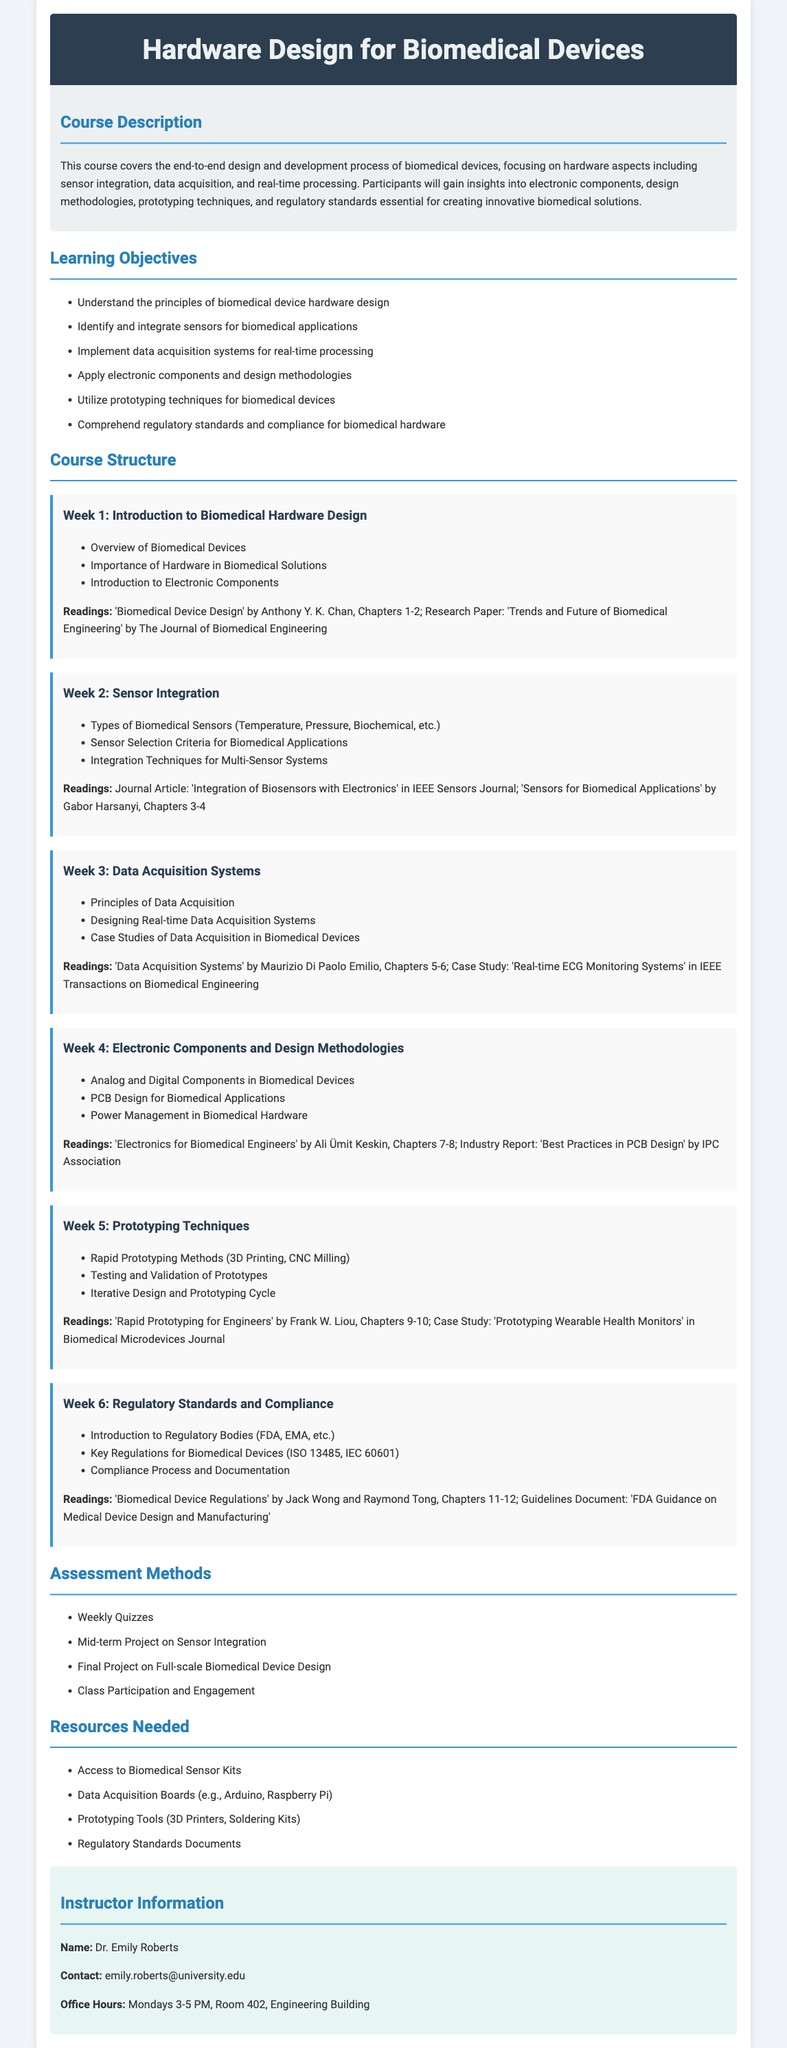What is the title of the course? The title of the course is listed at the beginning of the document.
Answer: Hardware Design for Biomedical Devices Who is the instructor for the course? The instructor's name is provided in the instructor section of the syllabus.
Answer: Dr. Emily Roberts What is Week 2 focused on? The week topics are described under the course structure heading, specifically for Week 2.
Answer: Sensor Integration What are the learning objectives of this course? The learning objectives are listed in a bulleted format under the learning objectives section.
Answer: Understand the principles of biomedical device hardware design What is the reading for Week 1? The readings for each week are specified right after the week's topics.
Answer: 'Biomedical Device Design' by Anthony Y. K. Chan, Chapters 1-2 What kind of assessment is mentioned for the course? Different types of assessments are detailed in the assessment methods section.
Answer: Weekly Quizzes Which regulatory bodies are introduced in Week 6? Specific regulatory bodies are highlighted in the week's topics concerning regulatory standards.
Answer: FDA, EMA What is one prototyping technique mentioned in the syllabus? Prototyping techniques are detailed under Week 5.
Answer: 3D Printing What tools are needed for prototyping according to the resources section? The resources needed are outlined, specifically for prototyping tools.
Answer: 3D Printers, Soldering Kits 